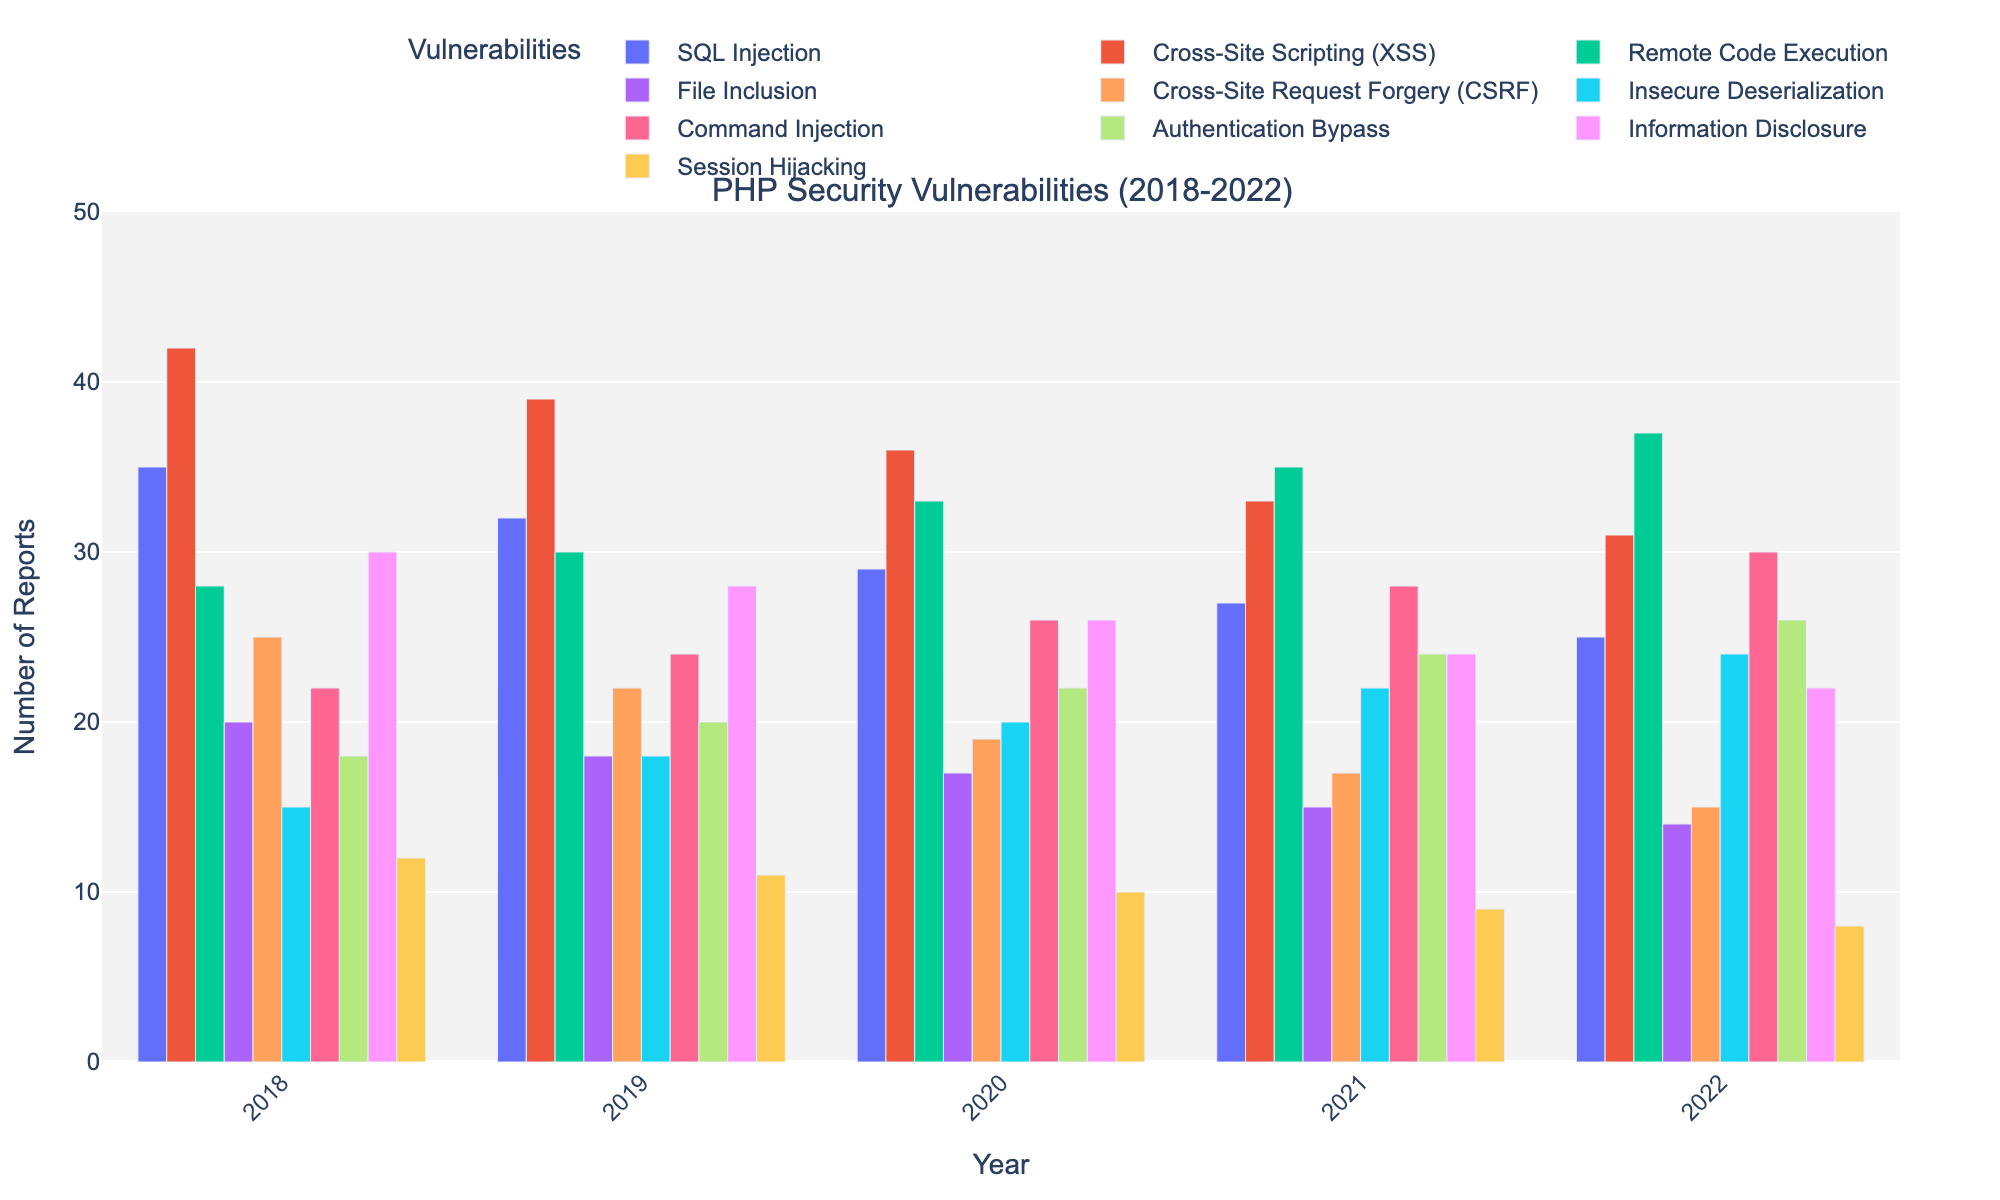What's the average number of SQL Injection reports over the 5 years? Add the number of reports for each year (35+32+29+27+25) to get 148. Then, divide by the total number of years (5) to get the average. Thus, 148/5 = 29.6
Answer: 29.6 Which vulnerability shows the largest increase in reports from 2018 to 2022? Compare the report numbers for each vulnerability between 2018 and 2022. Remote Code Execution reports increased from 28 in 2018 to 37 in 2022, which is an increase of 9. No other vulnerability shows a larger increase.
Answer: Remote Code Execution What is the trend of the number of File Inclusion reports from 2018 to 2022? Look at the number of File Inclusion reports for each year and observe the trend. The reports decrease from 20 in 2018 to 14 in 2022. Therefore, the trend is a gradual decline.
Answer: Gradual decline Which year had the highest number of Cross-Site Scripting (XSS) reports? Look at the XSS data across the years. The numbers are 42 (2018), 39 (2019), 36 (2020), 33 (2021), and 31 (2022). The highest number of reports is 42, which occurred in 2018.
Answer: 2018 Place the vulnerabilities in descending order based on the number of reports in 2022. Look at the number of reports for each vulnerability in 2022. The order from highest to lowest is: Remote Code Execution (37), Command Injection (30), Authentication Bypass (26), Cross-Site Scripting (31), SQL Injection (25), Insecure Deserialization (24), Information Disclosure (22), Cross-Site Request Forgery (15), File Inclusion (14), Session Hijacking (8).
Answer: Remote Code Execution, Command Injection, Authentication Bypass, Cross-Site Scripting, SQL Injection, Insecure Deserialization, Information Disclosure, Cross-Site Request Forgery, File Inclusion, Session Hijacking How did the number of Cross-Site Request Forgery (CSRF) reports change from 2018 to 2021? Check the CSRF data from 2018 to 2021: 25 (2018), 22 (2019), 19 (2020), and 17 (2021). The reports show a decrease over these years.
Answer: Decreased What is the combined total number of Session Hijacking reports for all five years? Add the number of reports from 2018 to 2022: 12+11+10+9+8 to get 50. Therefore, the combined total is 50.
Answer: 50 Is the number of Insecure Deserialization reports in 2022 higher than the number of SQL Injection reports in 2021? Compare the numbers: Insecure Deserialization has 24 reports in 2022, while SQL Injection has 27 reports in 2021. Therefore, Insecure Deserialization in 2022 is not higher.
Answer: No Which vulnerabilities show a consistent decreasing trend over the five years? Check each vulnerability's data for a consistent yearly decrease. Cross-Site Scripting (42, 39, 36, 33, 31), File Inclusion (20, 18, 17, 15, 14), Cross-Site Request Forgery (25, 22, 19, 17, 15), Information Disclosure (30, 28, 26, 24, 22), and Session Hijacking (12, 11, 10, 9, 8) show consistent declines.
Answer: Cross-Site Scripting, File Inclusion, Cross-Site Request Forgery, Information Disclosure, Session Hijacking Between which two consecutive years was the largest drop in Information Disclosure reports? Compare the yearly drop in reports: 
2018 to 2019: (30-28) = 2,
2019 to 2020: (28-26) = 2,
2020 to 2021: (26-24) = 2,
2021 to 2022: (24-22) = 2. 
All drops are equal, so there is no larger drop between any two consecutive years.
Answer: None, equal drops 